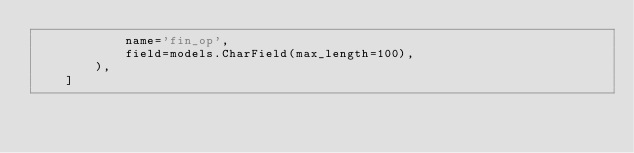<code> <loc_0><loc_0><loc_500><loc_500><_Python_>            name='fin_op',
            field=models.CharField(max_length=100),
        ),
    ]
</code> 